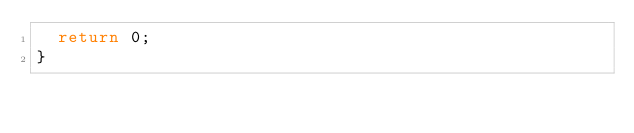Convert code to text. <code><loc_0><loc_0><loc_500><loc_500><_C++_>  return 0;
}
</code> 